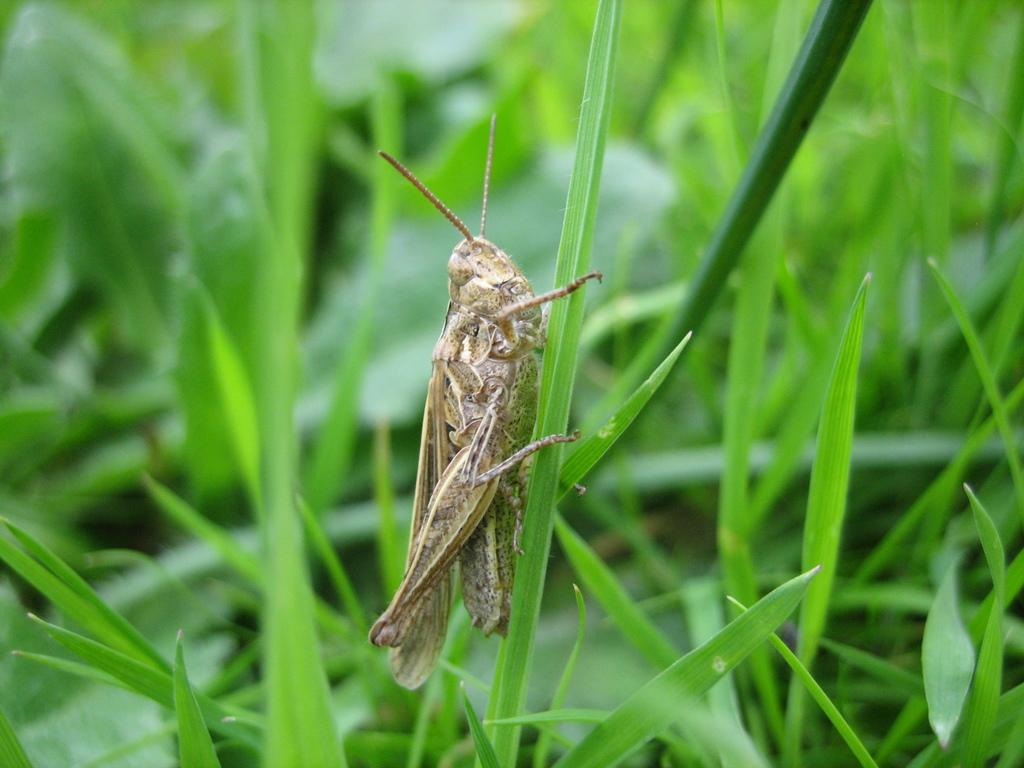What is present on the leaf in the image? There is an insect on the leaf in the image. What is the insect's immediate environment? The insect is surrounded by leaves in the image. What color are the balls that the yak is playing with in the image? There is no yak or balls present in the image; it features an insect on a leaf surrounded by other leaves. 